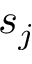Convert formula to latex. <formula><loc_0><loc_0><loc_500><loc_500>s _ { j }</formula> 